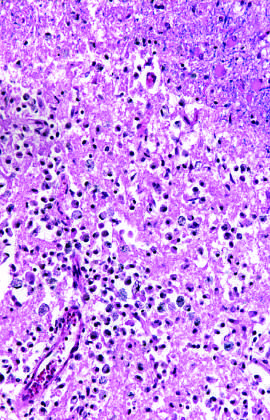what shows the presence of macrophages and surrounding reactive gliosis by day 10?
Answer the question using a single word or phrase. An area of infarction 